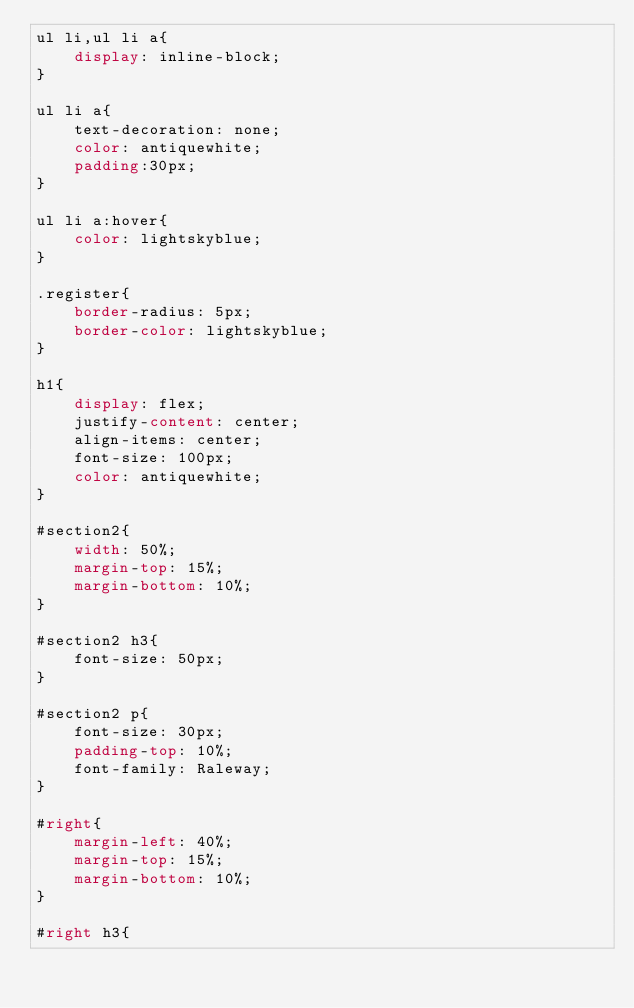Convert code to text. <code><loc_0><loc_0><loc_500><loc_500><_CSS_>ul li,ul li a{
    display: inline-block;
}

ul li a{
    text-decoration: none;
    color: antiquewhite;
    padding:30px;
}

ul li a:hover{
    color: lightskyblue;
}

.register{
    border-radius: 5px;
    border-color: lightskyblue;
}

h1{
    display: flex;
    justify-content: center;
    align-items: center;
    font-size: 100px;
    color: antiquewhite;
}

#section2{
    width: 50%;
    margin-top: 15%;
    margin-bottom: 10%;
}

#section2 h3{
    font-size: 50px;
}

#section2 p{
    font-size: 30px;
    padding-top: 10%;
    font-family: Raleway;
}

#right{
    margin-left: 40%;
    margin-top: 15%;
    margin-bottom: 10%;
}

#right h3{</code> 